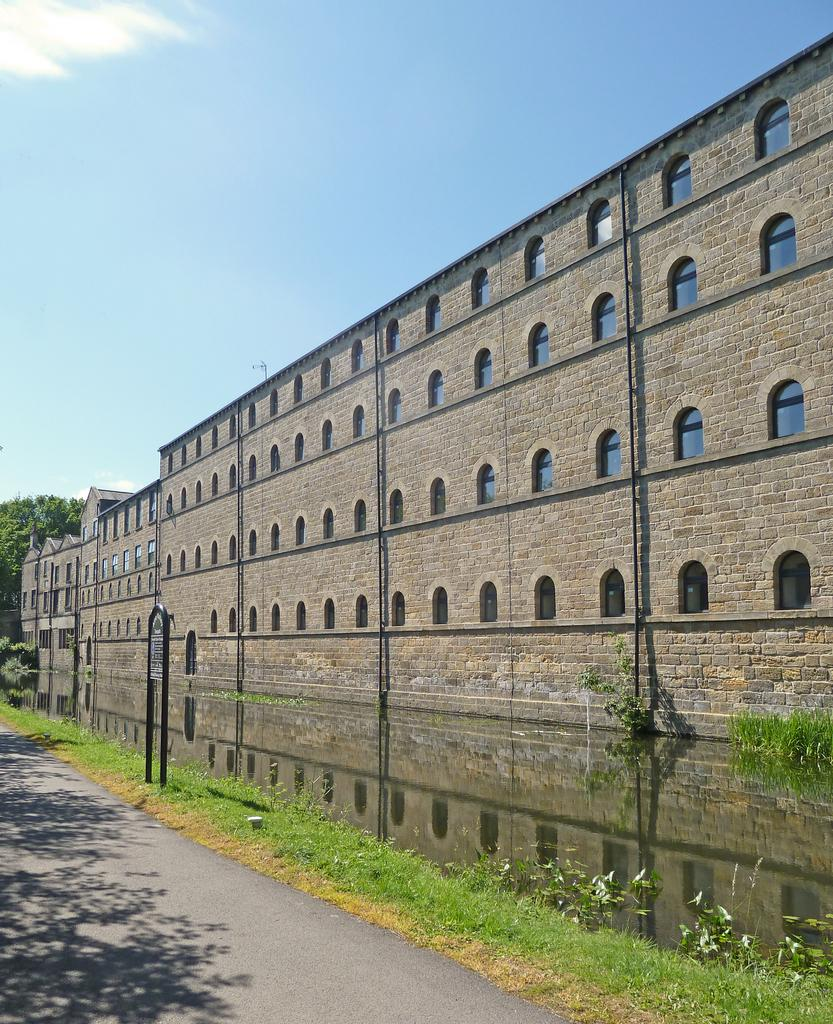What type of surface can be seen in the image? There is a road in the image. What can be found near the road? There is a name board in the image. What natural elements are present in the image? Water, grass, plants, and trees are visible in the image. What type of structures can be seen in the image? There are buildings with windows in the image. What is visible in the background of the image? The sky is visible in the background of the image. How many tomatoes are growing on the vase in the image? There is no vase or tomatoes present in the image. What type of competition is taking place in the image? There is no competition depicted in the image. 